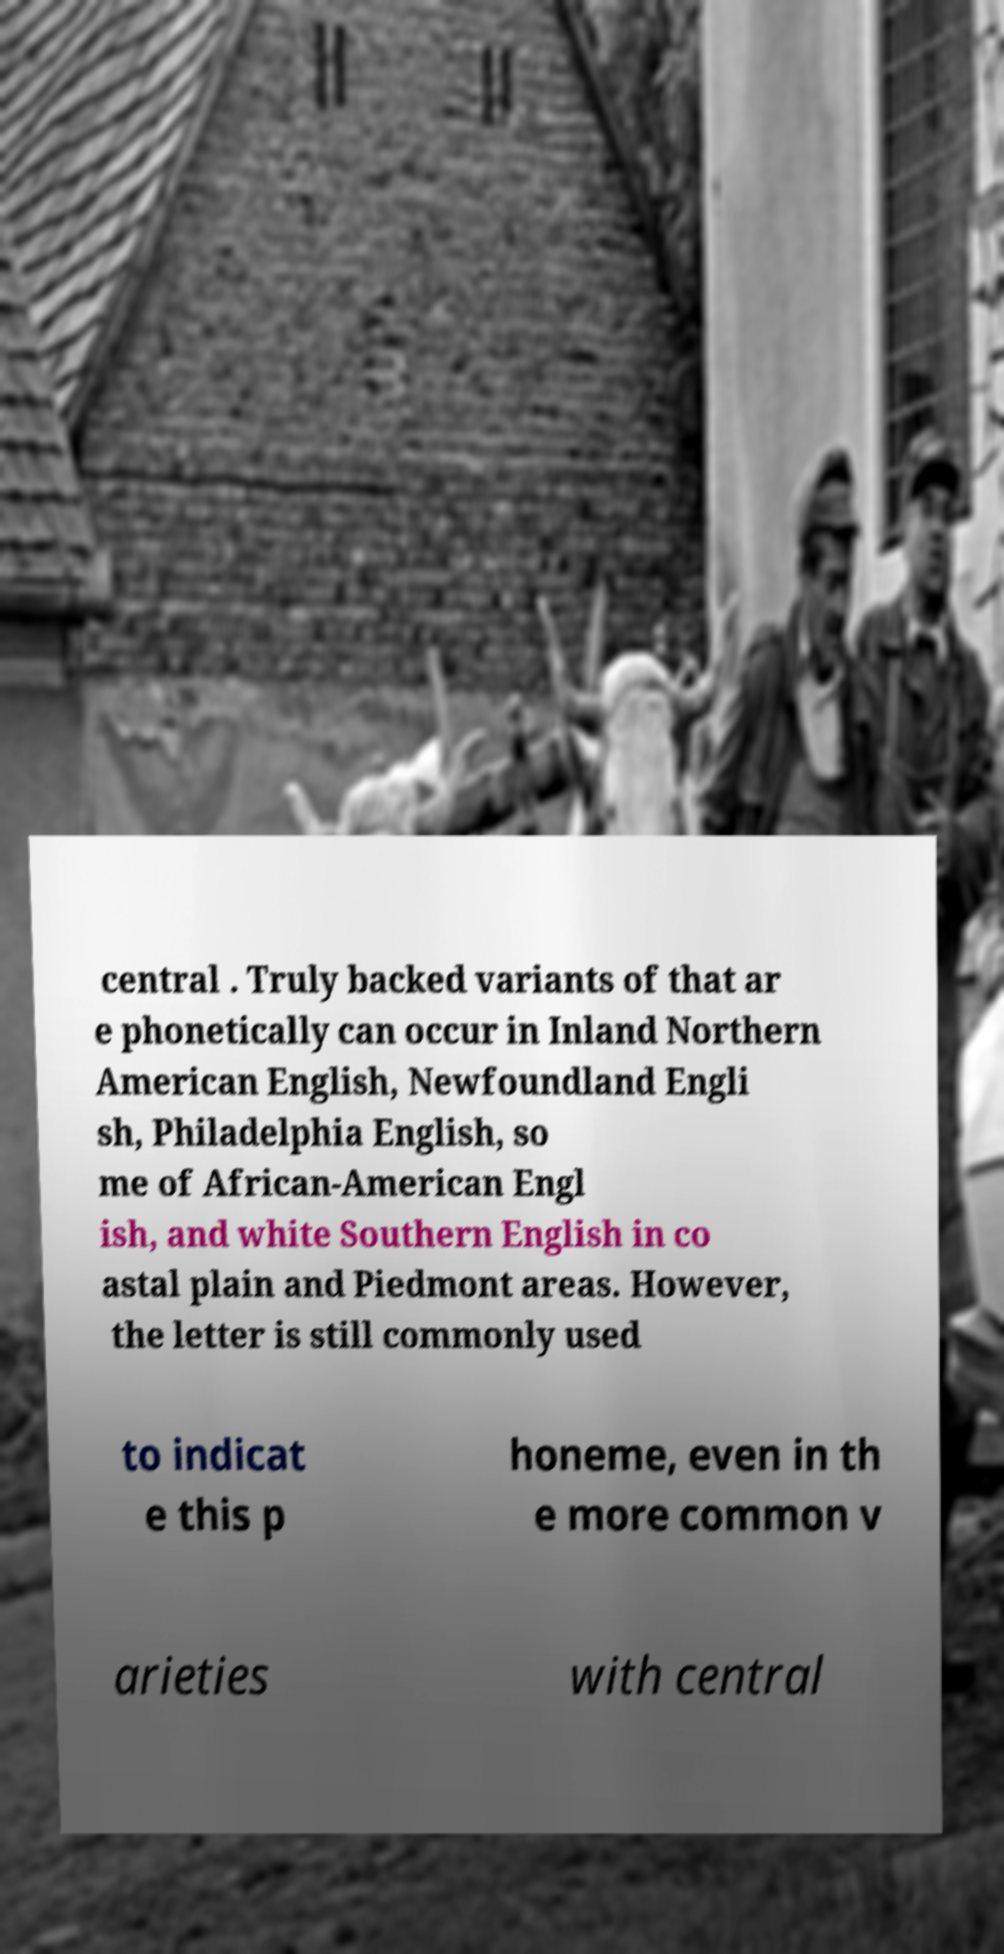There's text embedded in this image that I need extracted. Can you transcribe it verbatim? central . Truly backed variants of that ar e phonetically can occur in Inland Northern American English, Newfoundland Engli sh, Philadelphia English, so me of African-American Engl ish, and white Southern English in co astal plain and Piedmont areas. However, the letter is still commonly used to indicat e this p honeme, even in th e more common v arieties with central 